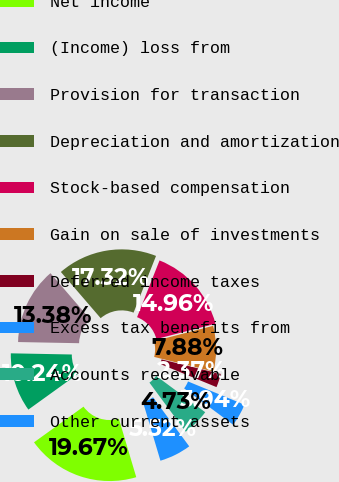<chart> <loc_0><loc_0><loc_500><loc_500><pie_chart><fcel>Net income<fcel>(Income) loss from<fcel>Provision for transaction<fcel>Depreciation and amortization<fcel>Stock-based compensation<fcel>Gain on sale of investments<fcel>Deferred income taxes<fcel>Excess tax benefits from<fcel>Accounts receivable<fcel>Other current assets<nl><fcel>19.67%<fcel>10.24%<fcel>13.38%<fcel>17.32%<fcel>14.96%<fcel>7.88%<fcel>2.37%<fcel>3.94%<fcel>4.73%<fcel>5.52%<nl></chart> 